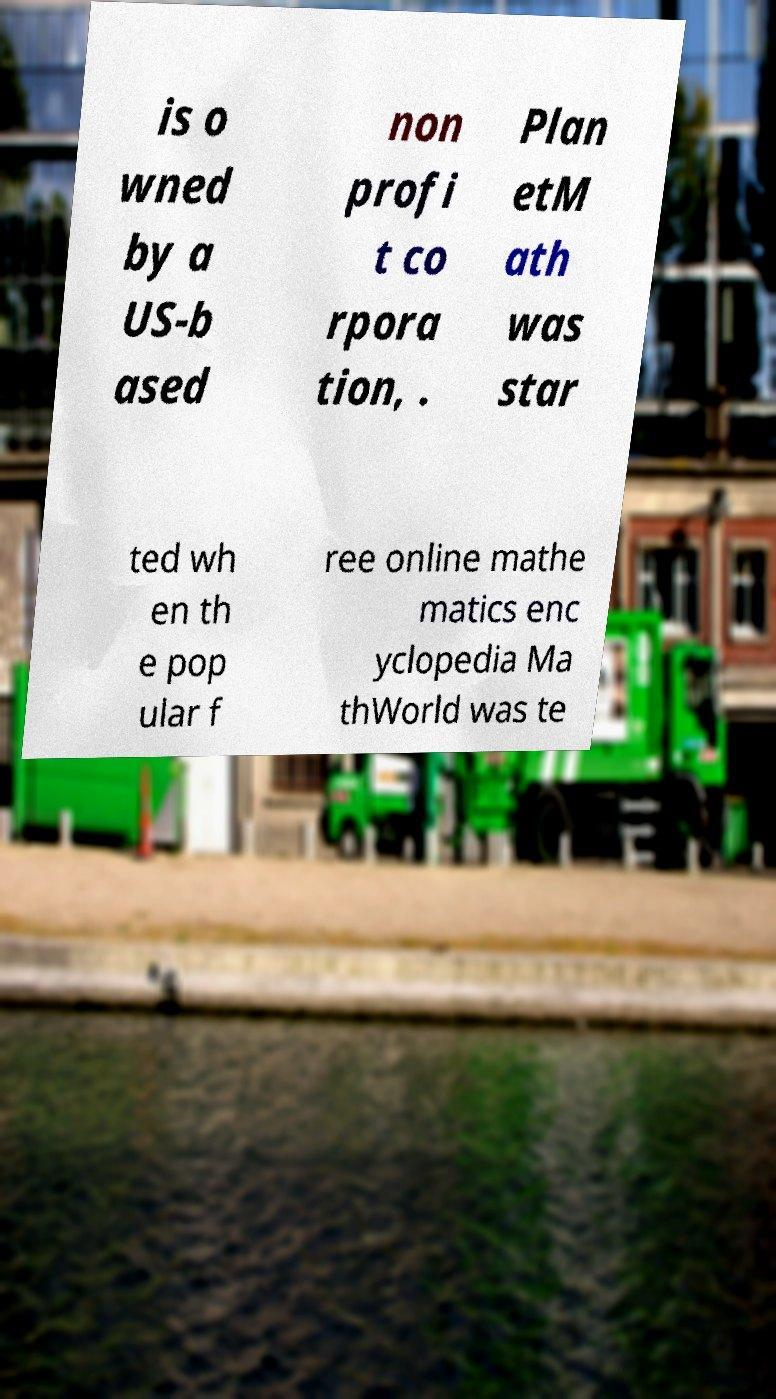Can you accurately transcribe the text from the provided image for me? is o wned by a US-b ased non profi t co rpora tion, . Plan etM ath was star ted wh en th e pop ular f ree online mathe matics enc yclopedia Ma thWorld was te 